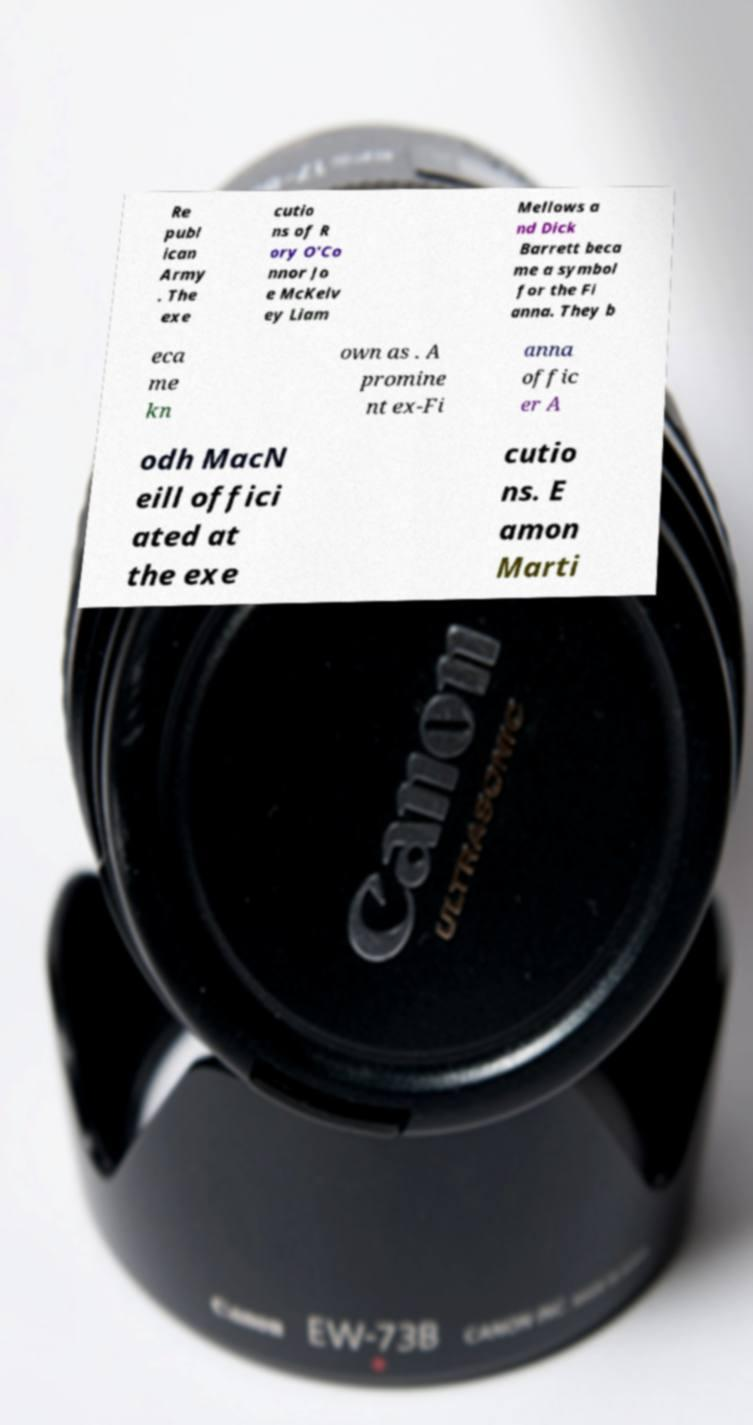Please identify and transcribe the text found in this image. Re publ ican Army . The exe cutio ns of R ory O'Co nnor Jo e McKelv ey Liam Mellows a nd Dick Barrett beca me a symbol for the Fi anna. They b eca me kn own as . A promine nt ex-Fi anna offic er A odh MacN eill offici ated at the exe cutio ns. E amon Marti 